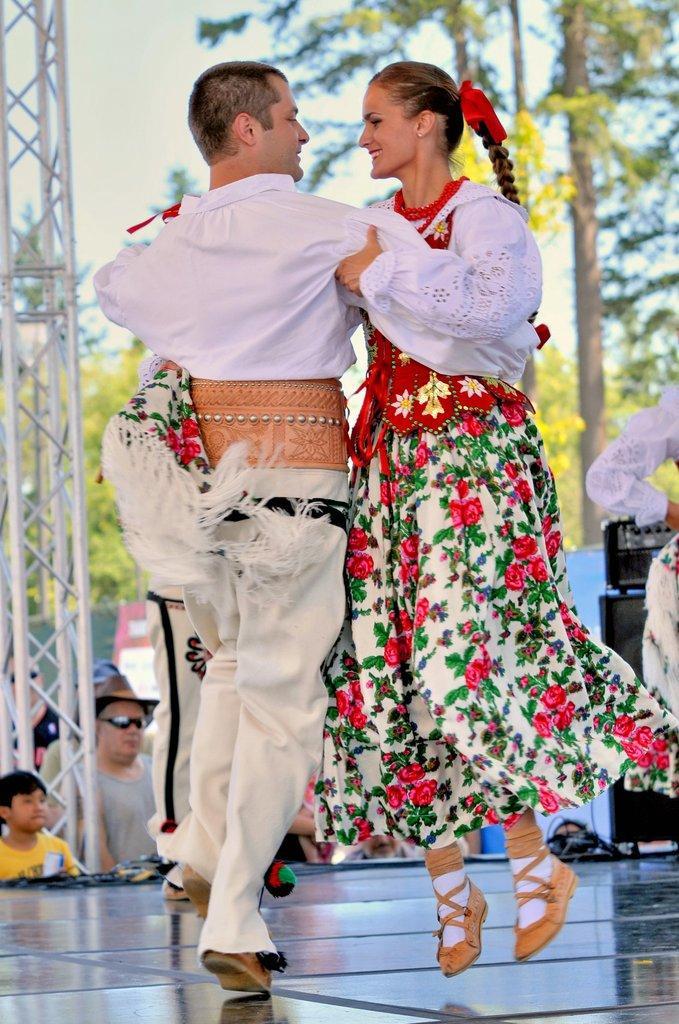Describe this image in one or two sentences. In this image we can see a man standing on the floor holding a woman. We can also see a group of people standing, a device on a table and some wires. ON the backside we can see a metal frame, a group of trees, a banner and the sky which looks cloudy. 